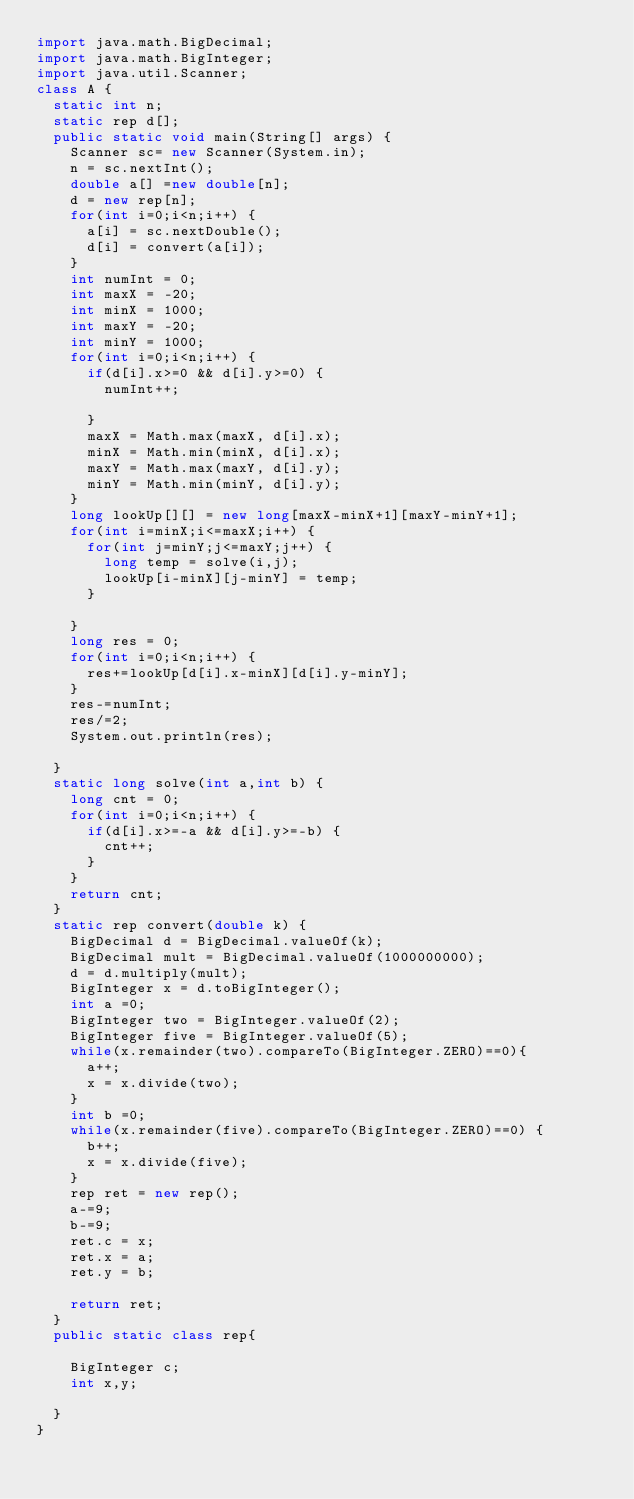Convert code to text. <code><loc_0><loc_0><loc_500><loc_500><_Java_>import java.math.BigDecimal;
import java.math.BigInteger;
import java.util.Scanner;
class A {
	static int n;
	static rep d[];
	public static void main(String[] args) {
		Scanner sc= new Scanner(System.in);
		n = sc.nextInt();
		double a[] =new double[n];
		d = new rep[n];
		for(int i=0;i<n;i++) {
			a[i] = sc.nextDouble();
			d[i] = convert(a[i]);
		}
		int numInt = 0;
		int maxX = -20;
		int minX = 1000;
		int maxY = -20;
		int minY = 1000;
		for(int i=0;i<n;i++) {
			if(d[i].x>=0 && d[i].y>=0) {
				numInt++;
				
			}
			maxX = Math.max(maxX, d[i].x);
			minX = Math.min(minX, d[i].x);
			maxY = Math.max(maxY, d[i].y);
			minY = Math.min(minY, d[i].y);
		}
		long lookUp[][] = new long[maxX-minX+1][maxY-minY+1];
		for(int i=minX;i<=maxX;i++) {
			for(int j=minY;j<=maxY;j++) {
				long temp = solve(i,j);
				lookUp[i-minX][j-minY] = temp;
			}
			
		}
		long res = 0;
		for(int i=0;i<n;i++) {
			res+=lookUp[d[i].x-minX][d[i].y-minY];
		}
		res-=numInt;
		res/=2;
		System.out.println(res);

	}
	static long solve(int a,int b) {
		long cnt = 0;
		for(int i=0;i<n;i++) {
			if(d[i].x>=-a && d[i].y>=-b) {
				cnt++;
			}
		}
		return cnt;
	}
	static rep convert(double k) {
		BigDecimal d = BigDecimal.valueOf(k);
		BigDecimal mult = BigDecimal.valueOf(1000000000);
		d = d.multiply(mult);
		BigInteger x = d.toBigInteger();
		int a =0;
		BigInteger two = BigInteger.valueOf(2);
		BigInteger five = BigInteger.valueOf(5);
		while(x.remainder(two).compareTo(BigInteger.ZERO)==0){
			a++;
			x = x.divide(two);
		}
		int b =0;
		while(x.remainder(five).compareTo(BigInteger.ZERO)==0) {
			b++;
			x = x.divide(five);
		}
		rep ret = new rep();
		a-=9;
		b-=9;
		ret.c = x;
		ret.x = a;
		ret.y = b;
		
		return ret;
	}
	public static class rep{
		
		BigInteger c;
		int x,y;
		
	}
}
</code> 